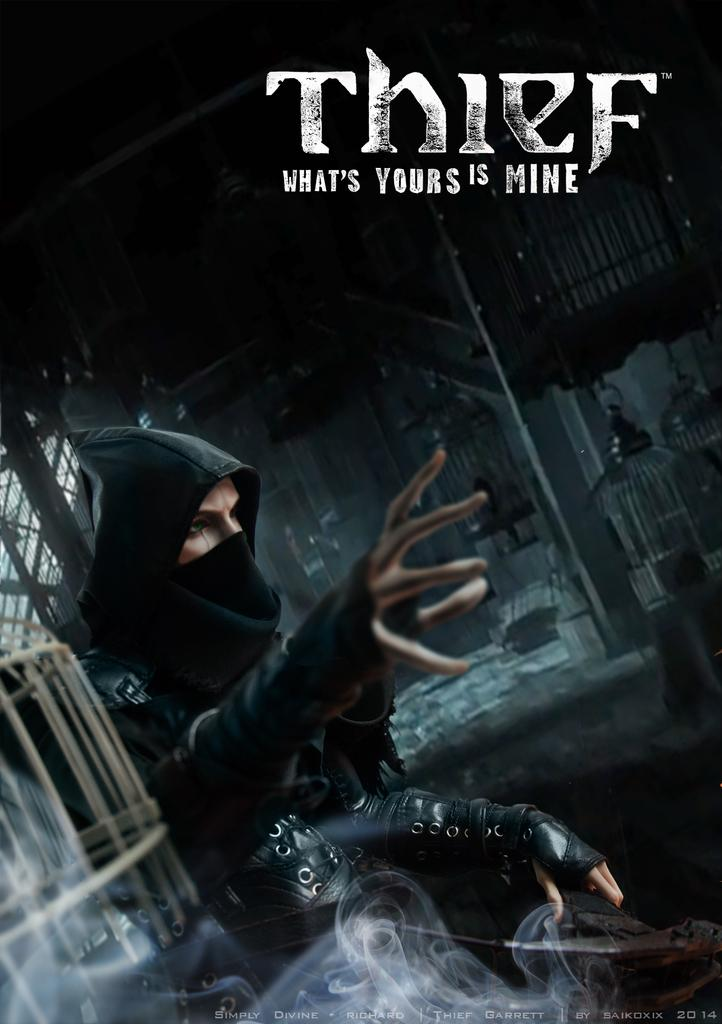What is the color of the poster in the image? The poster in the image is black. What can be found on the poster besides its color? The poster contains text and images. Can you describe the image on the poster? There is a man in a black dress in the poster. What else is present in the poster besides the man? There are objects on the ground in the poster. What is the price of the can in the image? There is no can present in the image; it only features a black poster with text, images, and objects on the ground. 